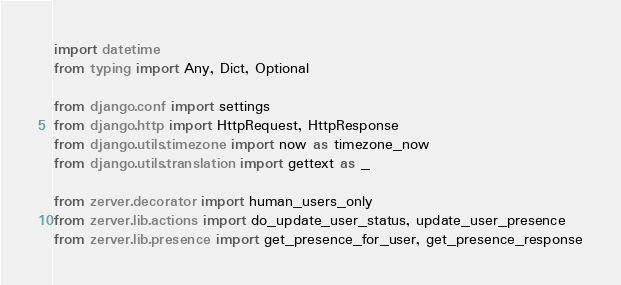<code> <loc_0><loc_0><loc_500><loc_500><_Python_>import datetime
from typing import Any, Dict, Optional

from django.conf import settings
from django.http import HttpRequest, HttpResponse
from django.utils.timezone import now as timezone_now
from django.utils.translation import gettext as _

from zerver.decorator import human_users_only
from zerver.lib.actions import do_update_user_status, update_user_presence
from zerver.lib.presence import get_presence_for_user, get_presence_response</code> 